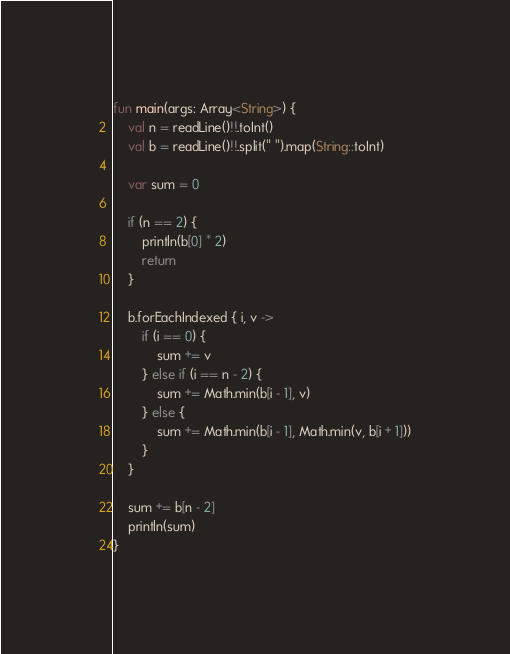<code> <loc_0><loc_0><loc_500><loc_500><_Kotlin_>fun main(args: Array<String>) {
    val n = readLine()!!.toInt()
    val b = readLine()!!.split(" ").map(String::toInt)

    var sum = 0

    if (n == 2) {
        println(b[0] * 2)
        return
    }

    b.forEachIndexed { i, v ->
        if (i == 0) {
            sum += v
        } else if (i == n - 2) {
            sum += Math.min(b[i - 1], v)
        } else {
            sum += Math.min(b[i - 1], Math.min(v, b[i + 1]))
        }
    }

    sum += b[n - 2]
    println(sum)
}
</code> 